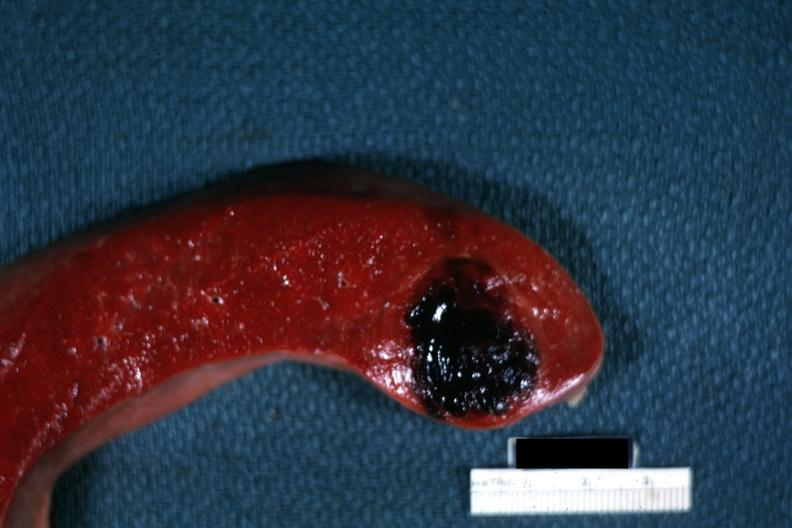what is present?
Answer the question using a single word or phrase. Spleen 